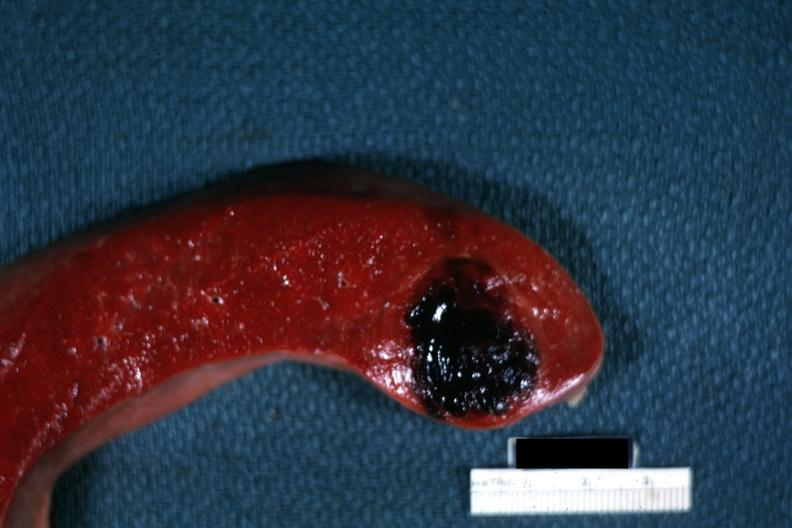what is present?
Answer the question using a single word or phrase. Spleen 